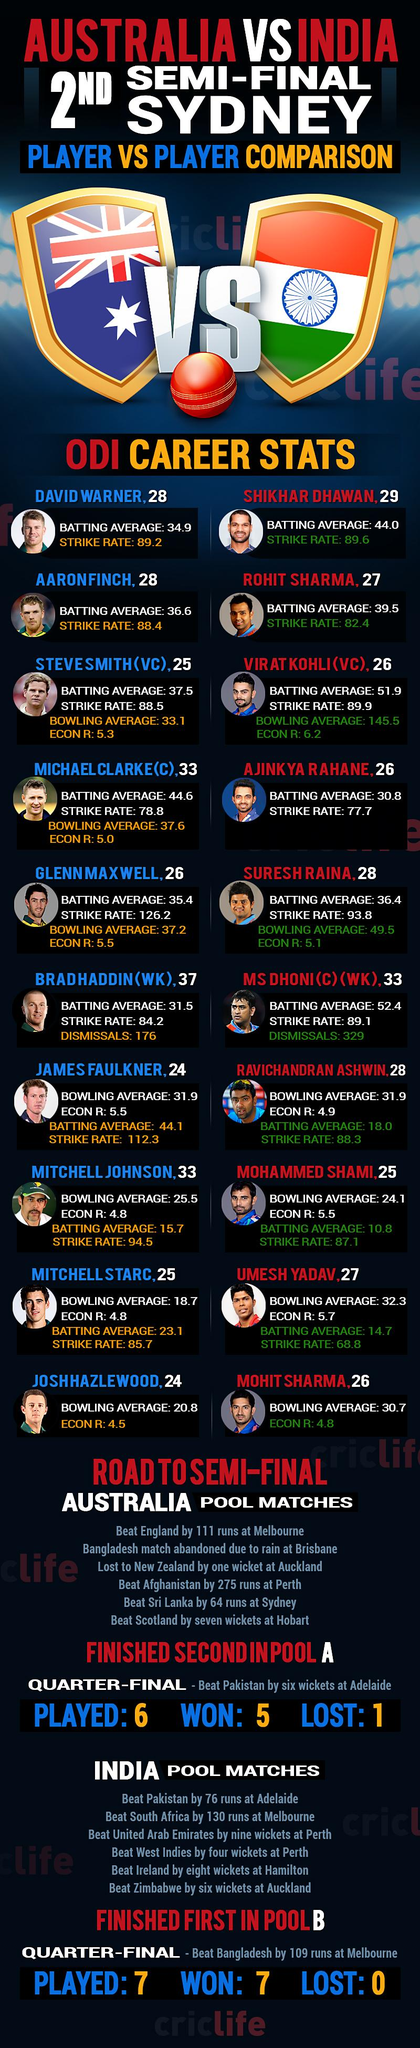Specify some key components in this picture. India has achieved a decisive victory over South Africa in a cricket match, winning by a significant margin of runs. Out of the 7 matches played by India, the percentage of wins is 100%. I declare that the wicket-keeper of the Australian cricket team is Brad Haddin. There are one or more players who have an age of 29. Umesh Yadav has a strike rate of 68.8, highlighting his ability to deliver a high number of deliveries in the batting zone. 